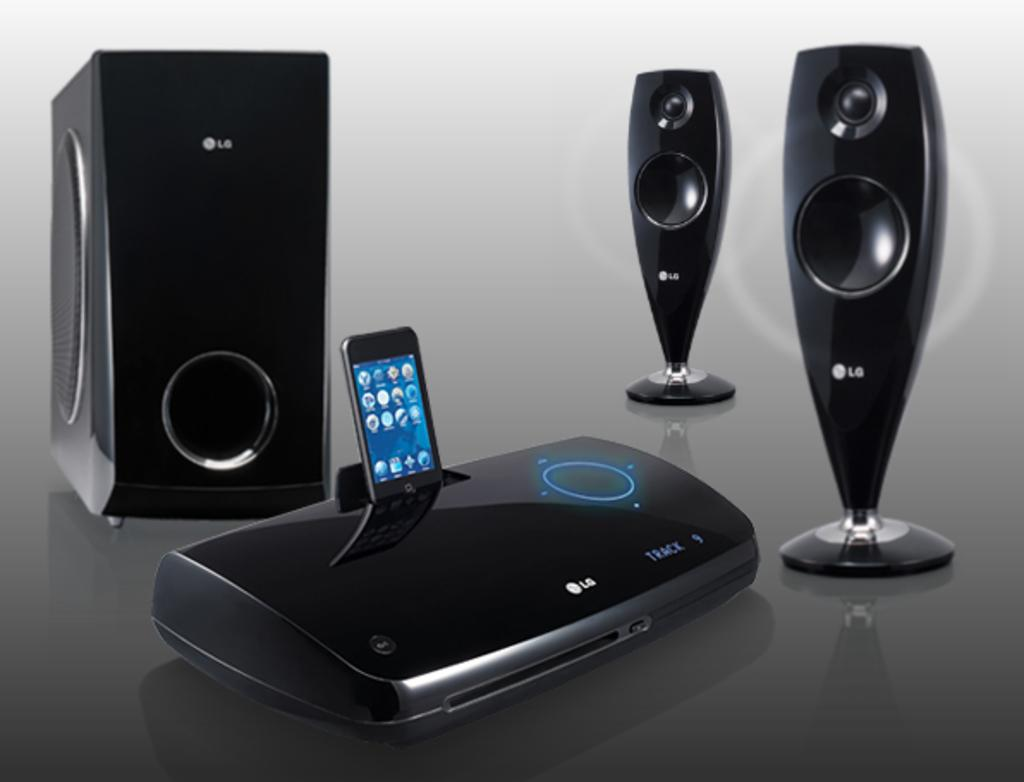<image>
Share a concise interpretation of the image provided. A set of LG speakers hooked up to a smart phone 